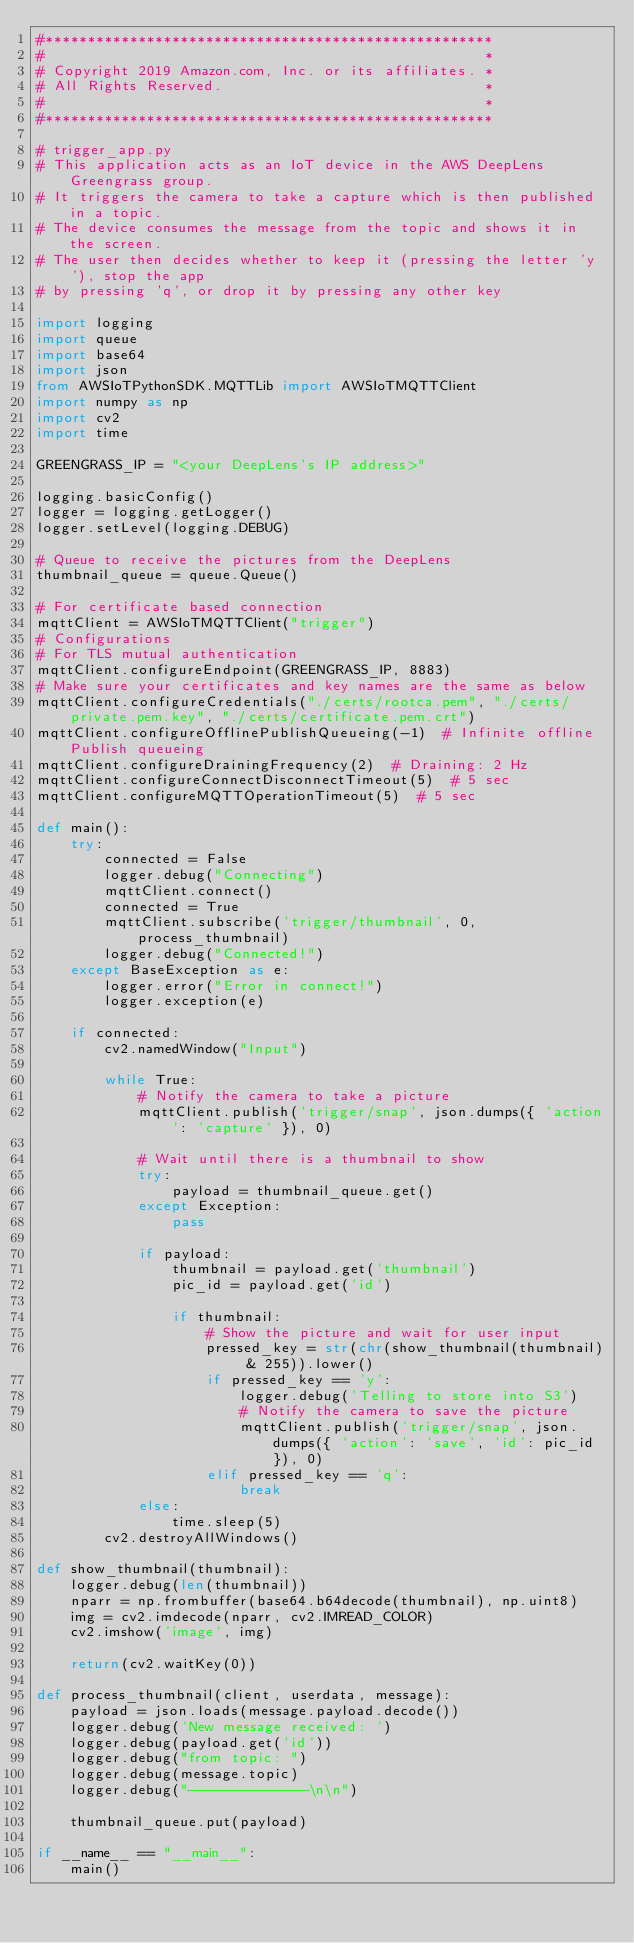<code> <loc_0><loc_0><loc_500><loc_500><_Python_>#*****************************************************
#                                                    *
# Copyright 2019 Amazon.com, Inc. or its affiliates. *
# All Rights Reserved.                               *
#                                                    *
#*****************************************************

# trigger_app.py
# This application acts as an IoT device in the AWS DeepLens Greengrass group.
# It triggers the camera to take a capture which is then published in a topic.
# The device consumes the message from the topic and shows it in the screen.
# The user then decides whether to keep it (pressing the letter 'y'), stop the app
# by pressing 'q', or drop it by pressing any other key

import logging
import queue
import base64
import json
from AWSIoTPythonSDK.MQTTLib import AWSIoTMQTTClient
import numpy as np
import cv2
import time

GREENGRASS_IP = "<your DeepLens's IP address>"

logging.basicConfig()
logger = logging.getLogger()
logger.setLevel(logging.DEBUG)

# Queue to receive the pictures from the DeepLens
thumbnail_queue = queue.Queue()

# For certificate based connection
mqttClient = AWSIoTMQTTClient("trigger")
# Configurations
# For TLS mutual authentication
mqttClient.configureEndpoint(GREENGRASS_IP, 8883)
# Make sure your certificates and key names are the same as below
mqttClient.configureCredentials("./certs/rootca.pem", "./certs/private.pem.key", "./certs/certificate.pem.crt")
mqttClient.configureOfflinePublishQueueing(-1)  # Infinite offline Publish queueing
mqttClient.configureDrainingFrequency(2)  # Draining: 2 Hz
mqttClient.configureConnectDisconnectTimeout(5)  # 5 sec
mqttClient.configureMQTTOperationTimeout(5)  # 5 sec

def main():
    try:
        connected = False
        logger.debug("Connecting")
        mqttClient.connect()
        connected = True
        mqttClient.subscribe('trigger/thumbnail', 0, process_thumbnail)
        logger.debug("Connected!")
    except BaseException as e:
        logger.error("Error in connect!")
        logger.exception(e)

    if connected:
        cv2.namedWindow("Input")

        while True:
            # Notify the camera to take a picture
            mqttClient.publish('trigger/snap', json.dumps({ 'action': 'capture' }), 0)

            # Wait until there is a thumbnail to show
            try:
                payload = thumbnail_queue.get()
            except Exception:
                pass
            
            if payload:
                thumbnail = payload.get('thumbnail')
                pic_id = payload.get('id')

                if thumbnail:
                    # Show the picture and wait for user input
                    pressed_key = str(chr(show_thumbnail(thumbnail) & 255)).lower()
                    if pressed_key == 'y':
                        logger.debug('Telling to store into S3')
                        # Notify the camera to save the picture
                        mqttClient.publish('trigger/snap', json.dumps({ 'action': 'save', 'id': pic_id }), 0)
                    elif pressed_key == 'q':
                        break
            else:
                time.sleep(5)
        cv2.destroyAllWindows()

def show_thumbnail(thumbnail):
    logger.debug(len(thumbnail))
    nparr = np.frombuffer(base64.b64decode(thumbnail), np.uint8)
    img = cv2.imdecode(nparr, cv2.IMREAD_COLOR)
    cv2.imshow('image', img)
    
    return(cv2.waitKey(0))

def process_thumbnail(client, userdata, message):
    payload = json.loads(message.payload.decode())
    logger.debug('New message received: ')
    logger.debug(payload.get('id'))
    logger.debug("from topic: ")
    logger.debug(message.topic)
    logger.debug("--------------\n\n")

    thumbnail_queue.put(payload)

if __name__ == "__main__":
    main()
</code> 